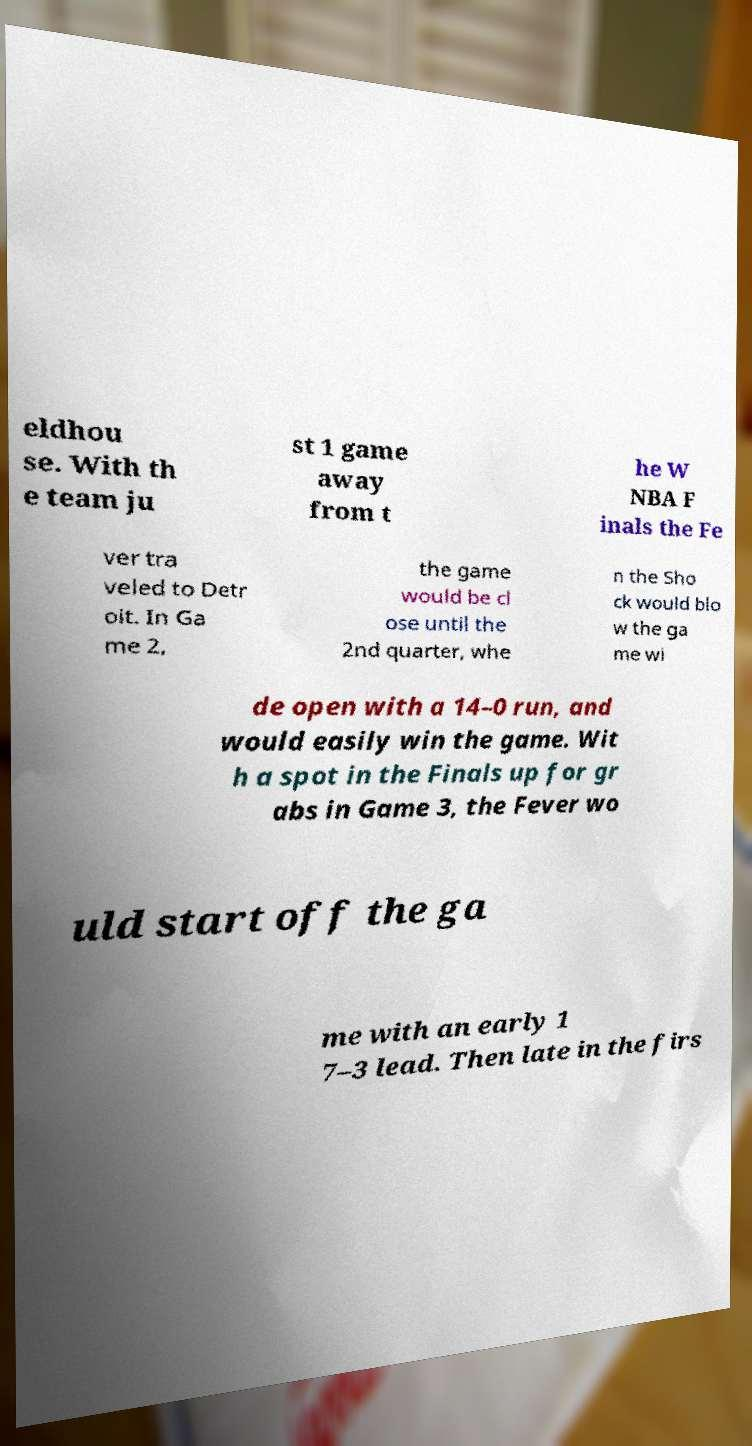Please identify and transcribe the text found in this image. eldhou se. With th e team ju st 1 game away from t he W NBA F inals the Fe ver tra veled to Detr oit. In Ga me 2, the game would be cl ose until the 2nd quarter, whe n the Sho ck would blo w the ga me wi de open with a 14–0 run, and would easily win the game. Wit h a spot in the Finals up for gr abs in Game 3, the Fever wo uld start off the ga me with an early 1 7–3 lead. Then late in the firs 